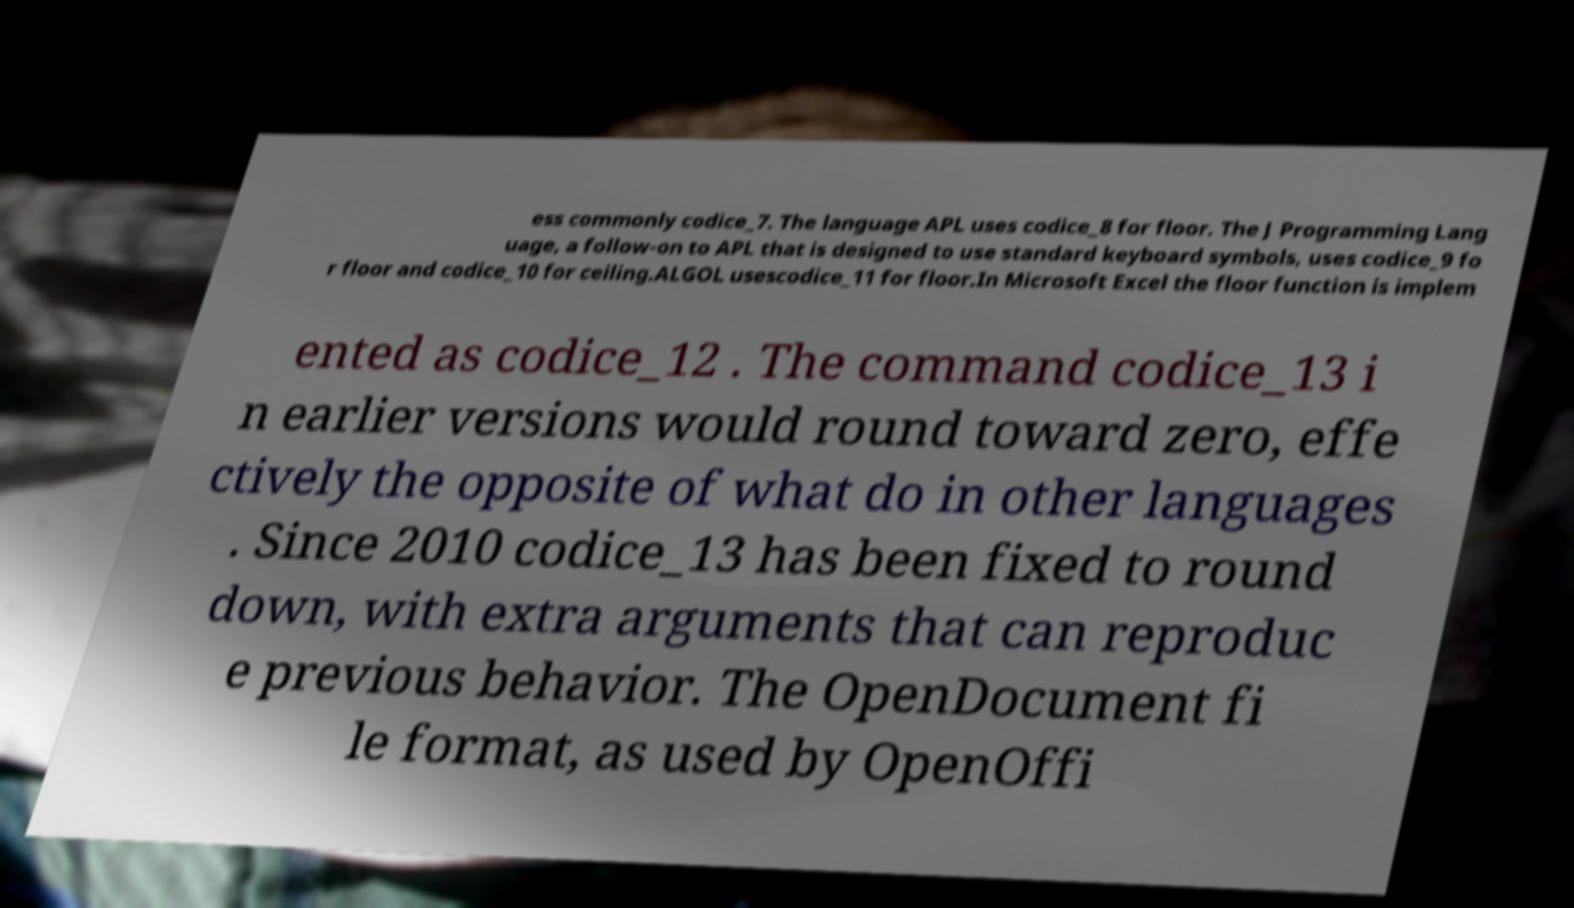Can you read and provide the text displayed in the image?This photo seems to have some interesting text. Can you extract and type it out for me? ess commonly codice_7. The language APL uses codice_8 for floor. The J Programming Lang uage, a follow-on to APL that is designed to use standard keyboard symbols, uses codice_9 fo r floor and codice_10 for ceiling.ALGOL usescodice_11 for floor.In Microsoft Excel the floor function is implem ented as codice_12 . The command codice_13 i n earlier versions would round toward zero, effe ctively the opposite of what do in other languages . Since 2010 codice_13 has been fixed to round down, with extra arguments that can reproduc e previous behavior. The OpenDocument fi le format, as used by OpenOffi 